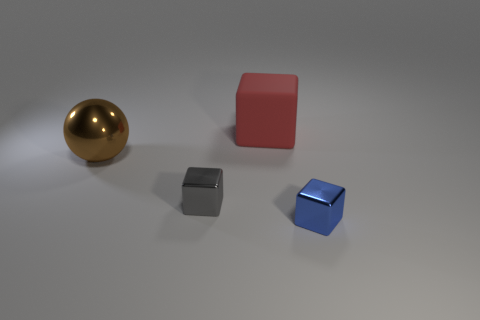How many small blue matte cylinders are there?
Offer a very short reply. 0. Are there an equal number of small shiny blocks that are in front of the metallic sphere and cubes on the right side of the small blue cube?
Your answer should be compact. No. There is a big red object; are there any small gray shiny things in front of it?
Your answer should be very brief. Yes. There is a block on the right side of the large red object; what is its color?
Your answer should be very brief. Blue. The tiny object that is left of the blue metallic cube in front of the big red block is made of what material?
Ensure brevity in your answer.  Metal. Is the number of blue metallic cubes that are left of the small blue object less than the number of big red matte things that are behind the brown thing?
Make the answer very short. Yes. How many gray things are either tiny metallic objects or big matte blocks?
Your response must be concise. 1. Is the number of tiny blue metal blocks that are behind the red block the same as the number of tiny cyan matte cylinders?
Offer a very short reply. Yes. What number of things are tiny purple rubber blocks or shiny things to the right of the large brown shiny ball?
Your response must be concise. 2. Is there a gray object made of the same material as the brown ball?
Offer a very short reply. Yes. 